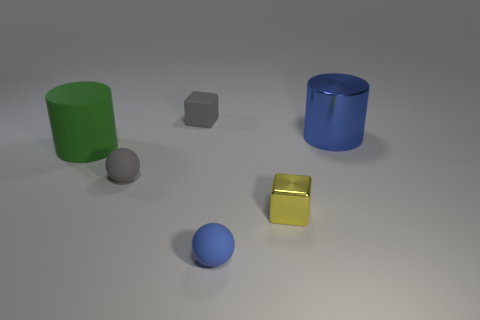Add 1 yellow rubber cubes. How many objects exist? 7 Subtract all spheres. How many objects are left? 4 Subtract 0 brown cylinders. How many objects are left? 6 Subtract all green matte cylinders. Subtract all brown shiny cylinders. How many objects are left? 5 Add 5 green things. How many green things are left? 6 Add 6 small yellow metallic cubes. How many small yellow metallic cubes exist? 7 